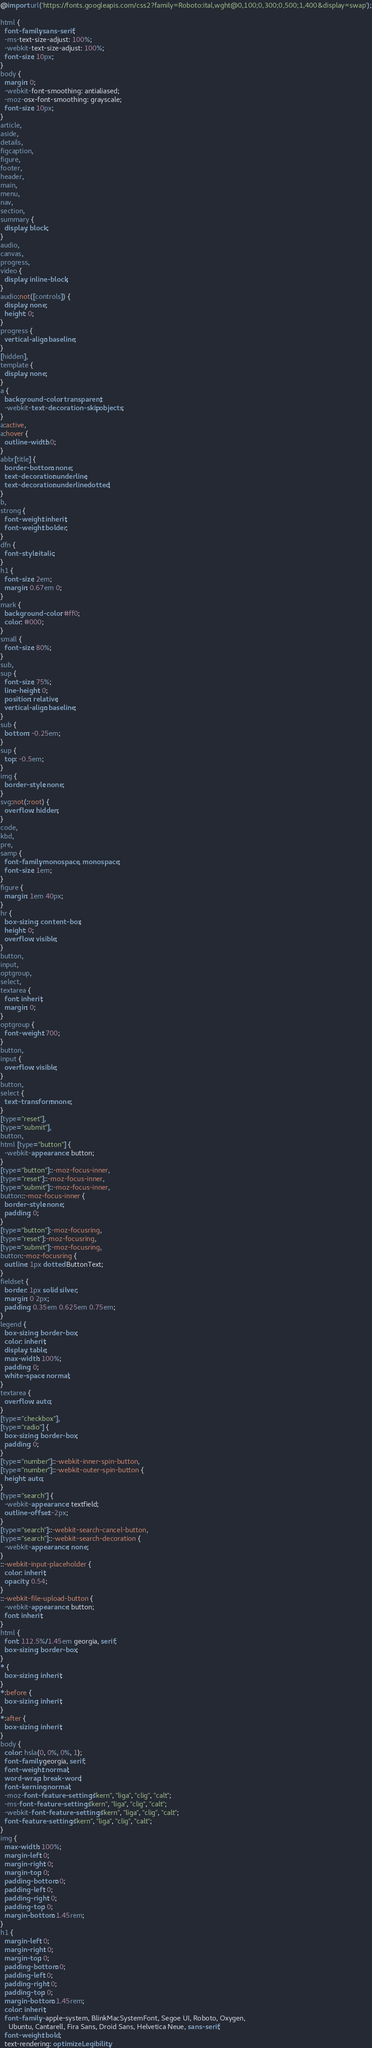Convert code to text. <code><loc_0><loc_0><loc_500><loc_500><_CSS_>@import url('https://fonts.googleapis.com/css2?family=Roboto:ital,wght@0,100;0,300;0,500;1,400&display=swap');

html {
  font-family: sans-serif;
  -ms-text-size-adjust: 100%;
  -webkit-text-size-adjust: 100%;
  font-size: 10px;
}
body {
  margin: 0;
  -webkit-font-smoothing: antialiased;
  -moz-osx-font-smoothing: grayscale;
  font-size: 10px;
}
article,
aside,
details,
figcaption,
figure,
footer,
header,
main,
menu,
nav,
section,
summary {
  display: block;
}
audio,
canvas,
progress,
video {
  display: inline-block;
}
audio:not([controls]) {
  display: none;
  height: 0;
}
progress {
  vertical-align: baseline;
}
[hidden],
template {
  display: none;
}
a {
  background-color: transparent;
  -webkit-text-decoration-skip: objects;
}
a:active,
a:hover {
  outline-width: 0;
}
abbr[title] {
  border-bottom: none;
  text-decoration: underline;
  text-decoration: underline dotted;
}
b,
strong {
  font-weight: inherit;
  font-weight: bolder;
}
dfn {
  font-style: italic;
}
h1 {
  font-size: 2em;
  margin: 0.67em 0;
}
mark {
  background-color: #ff0;
  color: #000;
}
small {
  font-size: 80%;
}
sub,
sup {
  font-size: 75%;
  line-height: 0;
  position: relative;
  vertical-align: baseline;
}
sub {
  bottom: -0.25em;
}
sup {
  top: -0.5em;
}
img {
  border-style: none;
}
svg:not(:root) {
  overflow: hidden;
}
code,
kbd,
pre,
samp {
  font-family: monospace, monospace;
  font-size: 1em;
}
figure {
  margin: 1em 40px;
}
hr {
  box-sizing: content-box;
  height: 0;
  overflow: visible;
}
button,
input,
optgroup,
select,
textarea {
  font: inherit;
  margin: 0;
}
optgroup {
  font-weight: 700;
}
button,
input {
  overflow: visible;
}
button,
select {
  text-transform: none;
}
[type="reset"],
[type="submit"],
button,
html [type="button"] {
  -webkit-appearance: button;
}
[type="button"]::-moz-focus-inner,
[type="reset"]::-moz-focus-inner,
[type="submit"]::-moz-focus-inner,
button::-moz-focus-inner {
  border-style: none;
  padding: 0;
}
[type="button"]:-moz-focusring,
[type="reset"]:-moz-focusring,
[type="submit"]:-moz-focusring,
button:-moz-focusring {
  outline: 1px dotted ButtonText;
}
fieldset {
  border: 1px solid silver;
  margin: 0 2px;
  padding: 0.35em 0.625em 0.75em;
}
legend {
  box-sizing: border-box;
  color: inherit;
  display: table;
  max-width: 100%;
  padding: 0;
  white-space: normal;
}
textarea {
  overflow: auto;
}
[type="checkbox"],
[type="radio"] {
  box-sizing: border-box;
  padding: 0;
}
[type="number"]::-webkit-inner-spin-button,
[type="number"]::-webkit-outer-spin-button {
  height: auto;
}
[type="search"] {
  -webkit-appearance: textfield;
  outline-offset: -2px;
}
[type="search"]::-webkit-search-cancel-button,
[type="search"]::-webkit-search-decoration {
  -webkit-appearance: none;
}
::-webkit-input-placeholder {
  color: inherit;
  opacity: 0.54;
}
::-webkit-file-upload-button {
  -webkit-appearance: button;
  font: inherit;
}
html {
  font: 112.5%/1.45em georgia, serif;
  box-sizing: border-box;
}
* {
  box-sizing: inherit;
}
*:before {
  box-sizing: inherit;
}
*:after {
  box-sizing: inherit;
}
body {
  color: hsla(0, 0%, 0%, 1);
  font-family: georgia, serif;
  font-weight: normal;
  word-wrap: break-word;
  font-kerning: normal;
  -moz-font-feature-settings: "kern", "liga", "clig", "calt";
  -ms-font-feature-settings: "kern", "liga", "clig", "calt";
  -webkit-font-feature-settings: "kern", "liga", "clig", "calt";
  font-feature-settings: "kern", "liga", "clig", "calt";
}
img {
  max-width: 100%;
  margin-left: 0;
  margin-right: 0;
  margin-top: 0;
  padding-bottom: 0;
  padding-left: 0;
  padding-right: 0;
  padding-top: 0;
  margin-bottom: 1.45rem;
}
h1 {
  margin-left: 0;
  margin-right: 0;
  margin-top: 0;
  padding-bottom: 0;
  padding-left: 0;
  padding-right: 0;
  padding-top: 0;
  margin-bottom: 1.45rem;
  color: inherit;
  font-family: -apple-system, BlinkMacSystemFont, Segoe UI, Roboto, Oxygen,
    Ubuntu, Cantarell, Fira Sans, Droid Sans, Helvetica Neue, sans-serif;
  font-weight: bold;
  text-rendering: optimizeLegibility;</code> 